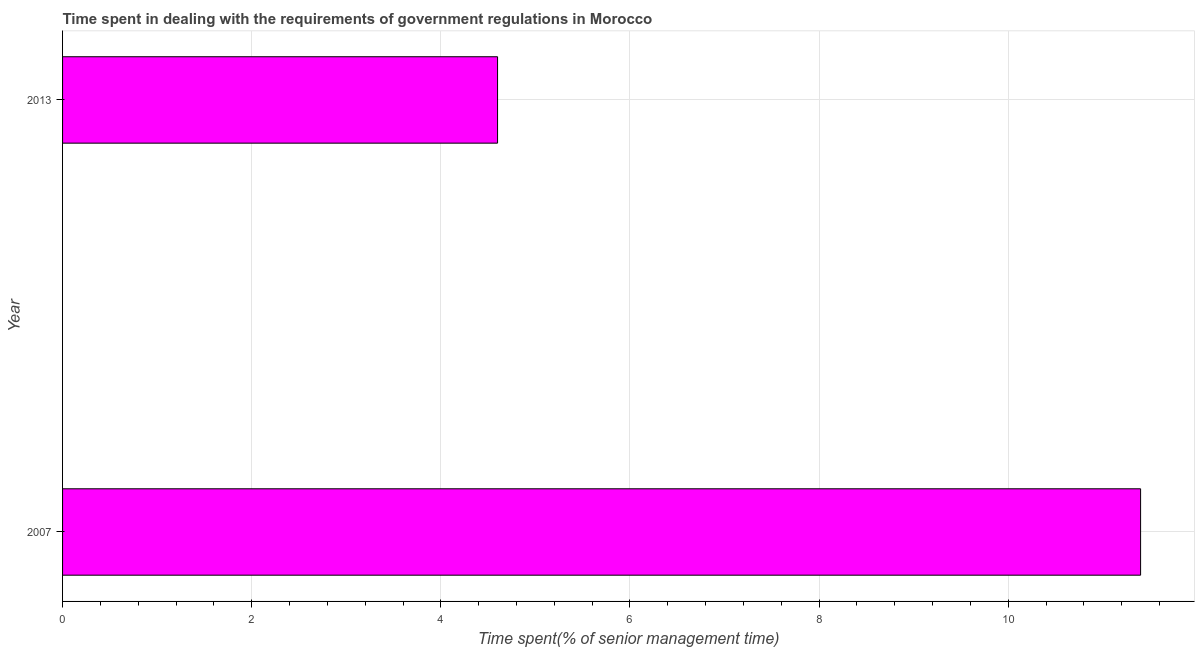What is the title of the graph?
Offer a very short reply. Time spent in dealing with the requirements of government regulations in Morocco. What is the label or title of the X-axis?
Offer a very short reply. Time spent(% of senior management time). What is the time spent in dealing with government regulations in 2007?
Your response must be concise. 11.4. Across all years, what is the minimum time spent in dealing with government regulations?
Your answer should be very brief. 4.6. What is the sum of the time spent in dealing with government regulations?
Your answer should be compact. 16. What is the difference between the time spent in dealing with government regulations in 2007 and 2013?
Make the answer very short. 6.8. What is the average time spent in dealing with government regulations per year?
Ensure brevity in your answer.  8. What is the median time spent in dealing with government regulations?
Give a very brief answer. 8. In how many years, is the time spent in dealing with government regulations greater than 2.8 %?
Ensure brevity in your answer.  2. Do a majority of the years between 2007 and 2013 (inclusive) have time spent in dealing with government regulations greater than 1.2 %?
Your answer should be compact. Yes. What is the ratio of the time spent in dealing with government regulations in 2007 to that in 2013?
Offer a very short reply. 2.48. Is the time spent in dealing with government regulations in 2007 less than that in 2013?
Keep it short and to the point. No. In how many years, is the time spent in dealing with government regulations greater than the average time spent in dealing with government regulations taken over all years?
Your answer should be compact. 1. What is the difference between two consecutive major ticks on the X-axis?
Give a very brief answer. 2. Are the values on the major ticks of X-axis written in scientific E-notation?
Ensure brevity in your answer.  No. What is the difference between the Time spent(% of senior management time) in 2007 and 2013?
Your answer should be very brief. 6.8. What is the ratio of the Time spent(% of senior management time) in 2007 to that in 2013?
Offer a very short reply. 2.48. 